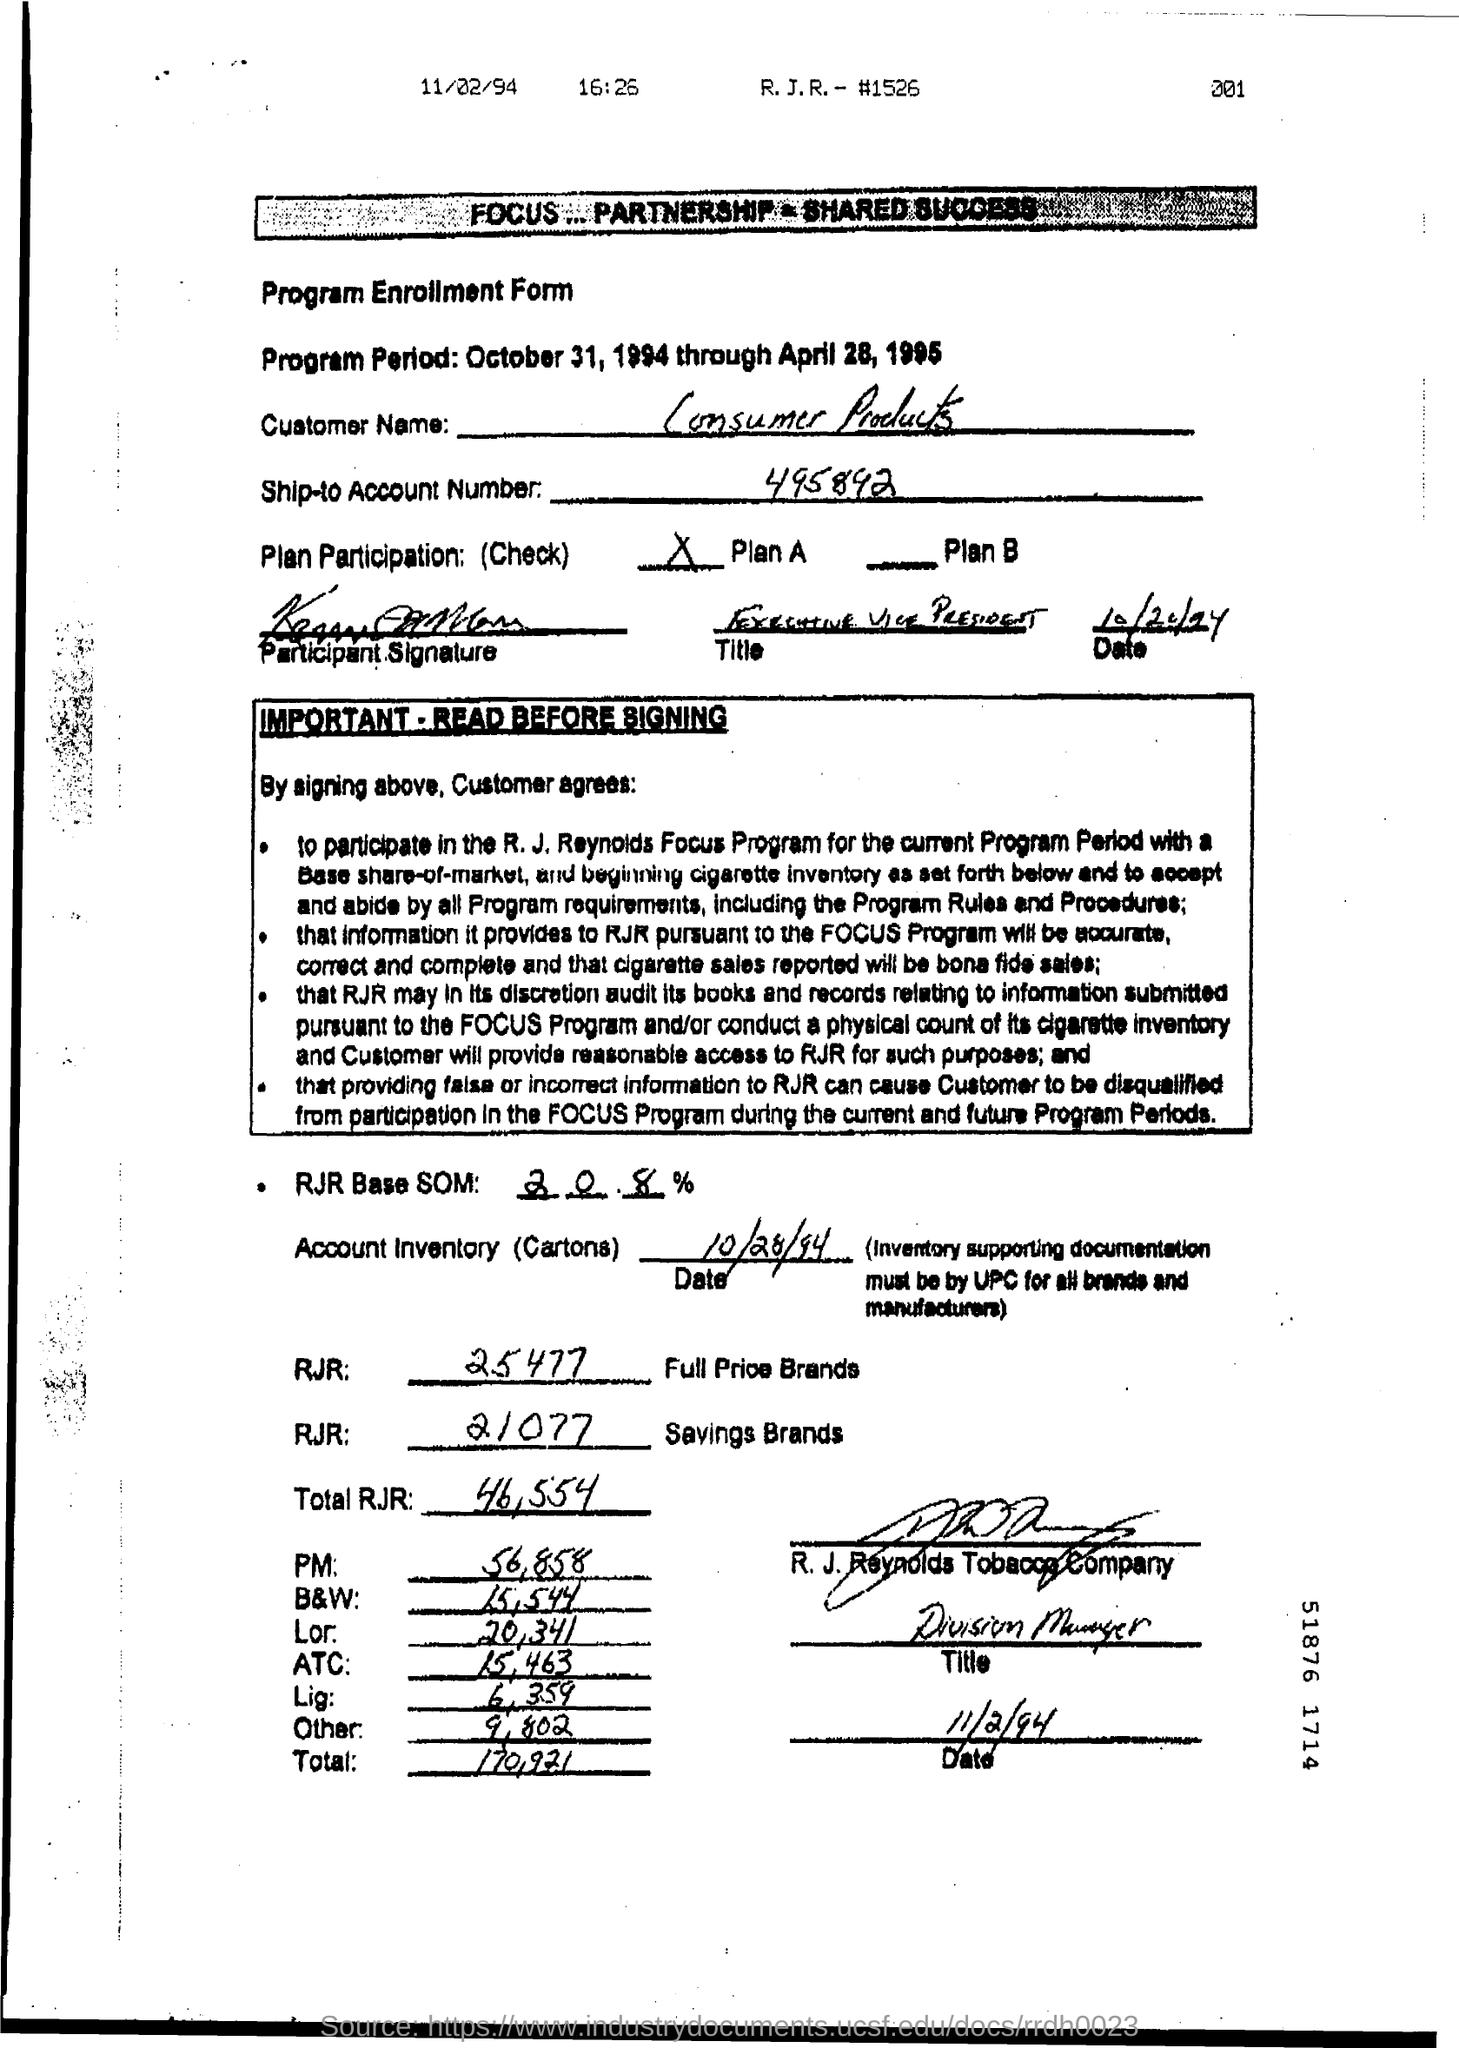Can you tell me more about the purpose of this document? Certainly! The document is a Program Enrollment Form for the R. J. Reynolds Focus Program. It outlines the program period, customer engagement terms, and inventory requirements related to the sale of tobacco products. What was the date this form was processed? The form was processed on November 2, 1994, at 16:25, as indicated by the timestamp in the top-right corner of the page. 